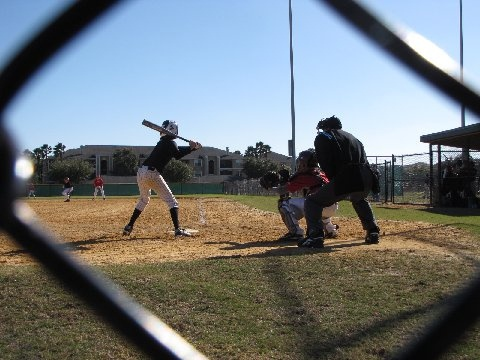Describe the objects in this image and their specific colors. I can see people in darkgray, black, gray, white, and olive tones, people in darkgray, black, gray, and maroon tones, people in darkgray, black, gray, and brown tones, people in darkgray, maroon, black, and gray tones, and people in darkgray, black, and gray tones in this image. 